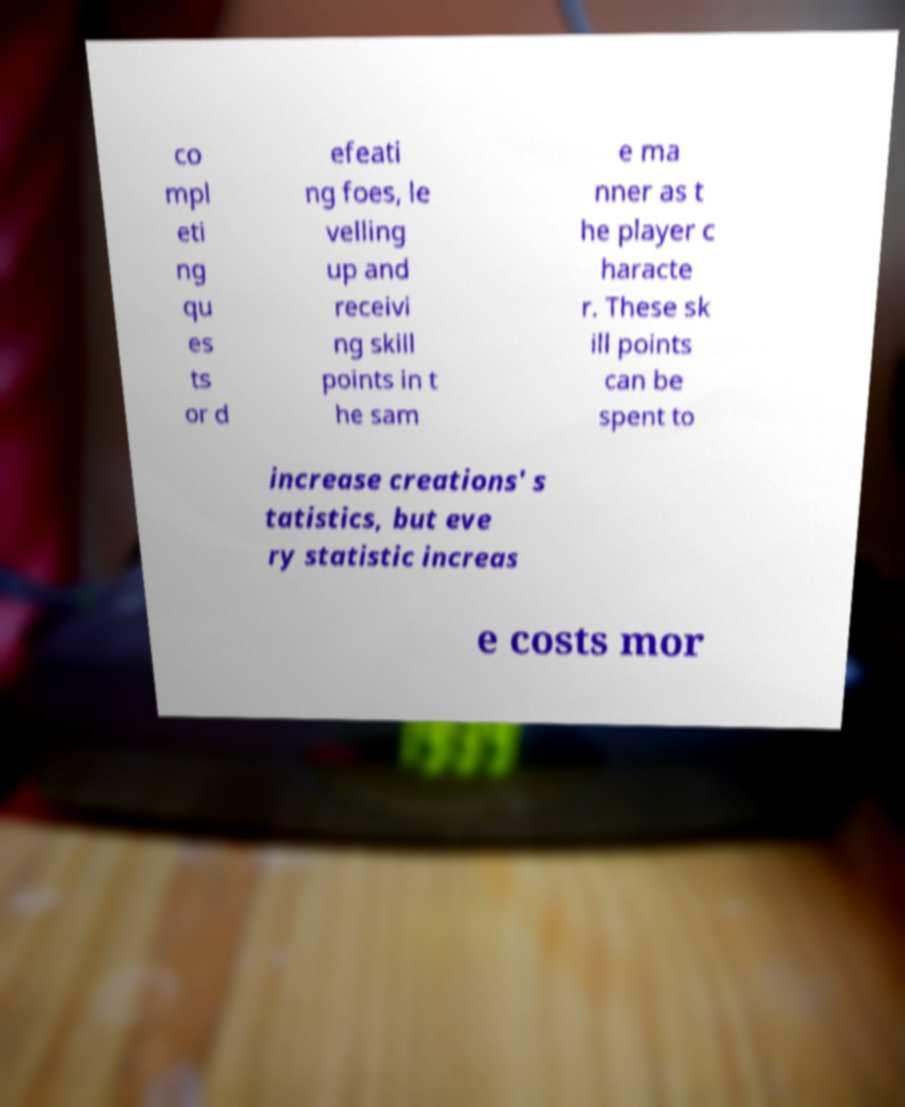Can you read and provide the text displayed in the image?This photo seems to have some interesting text. Can you extract and type it out for me? co mpl eti ng qu es ts or d efeati ng foes, le velling up and receivi ng skill points in t he sam e ma nner as t he player c haracte r. These sk ill points can be spent to increase creations' s tatistics, but eve ry statistic increas e costs mor 